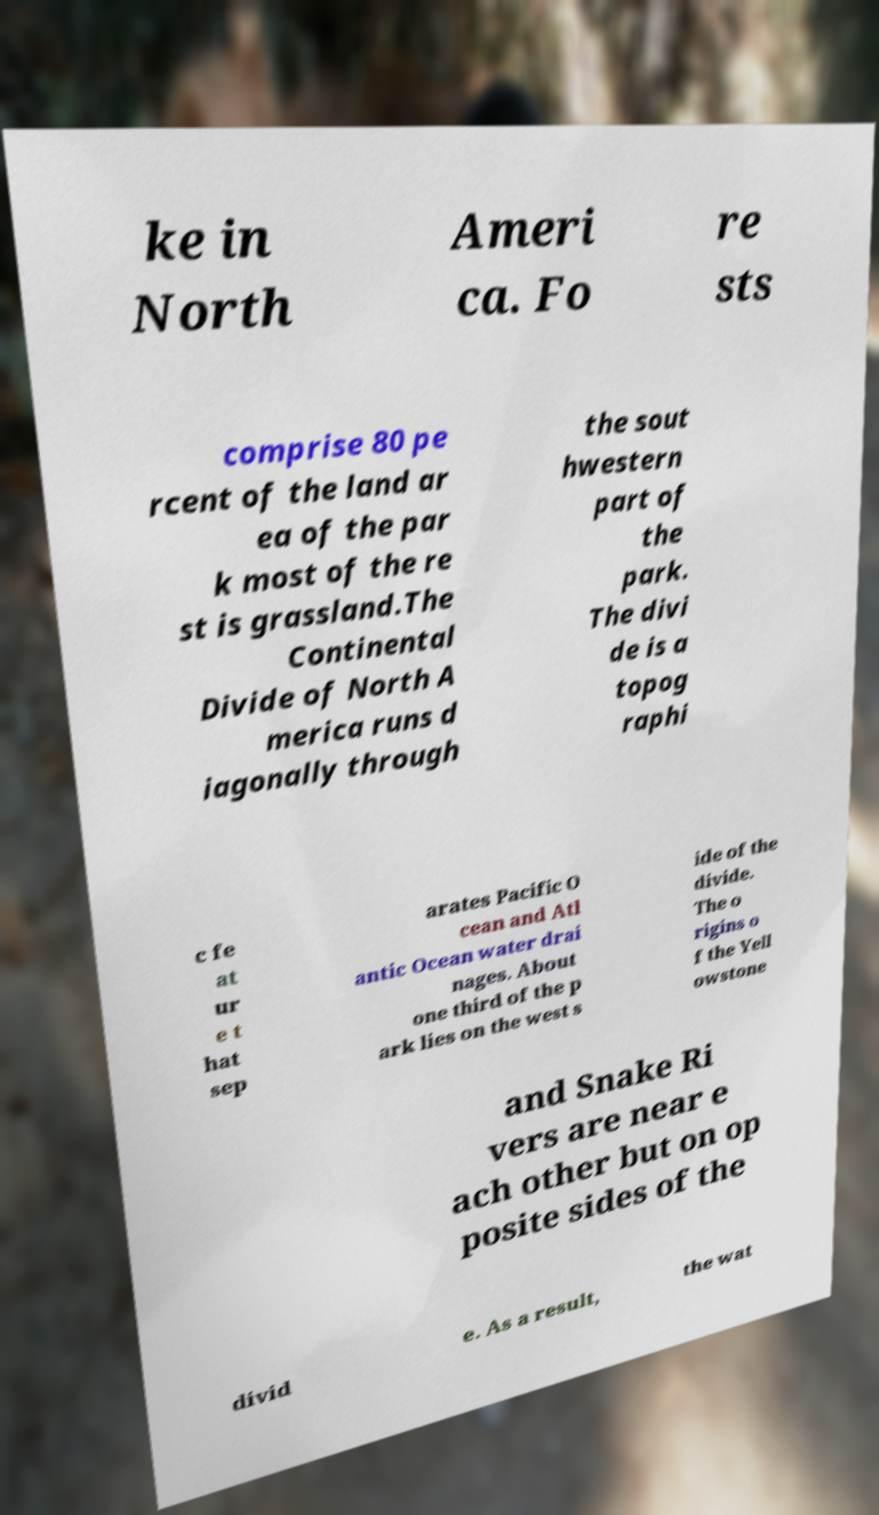Could you assist in decoding the text presented in this image and type it out clearly? ke in North Ameri ca. Fo re sts comprise 80 pe rcent of the land ar ea of the par k most of the re st is grassland.The Continental Divide of North A merica runs d iagonally through the sout hwestern part of the park. The divi de is a topog raphi c fe at ur e t hat sep arates Pacific O cean and Atl antic Ocean water drai nages. About one third of the p ark lies on the west s ide of the divide. The o rigins o f the Yell owstone and Snake Ri vers are near e ach other but on op posite sides of the divid e. As a result, the wat 